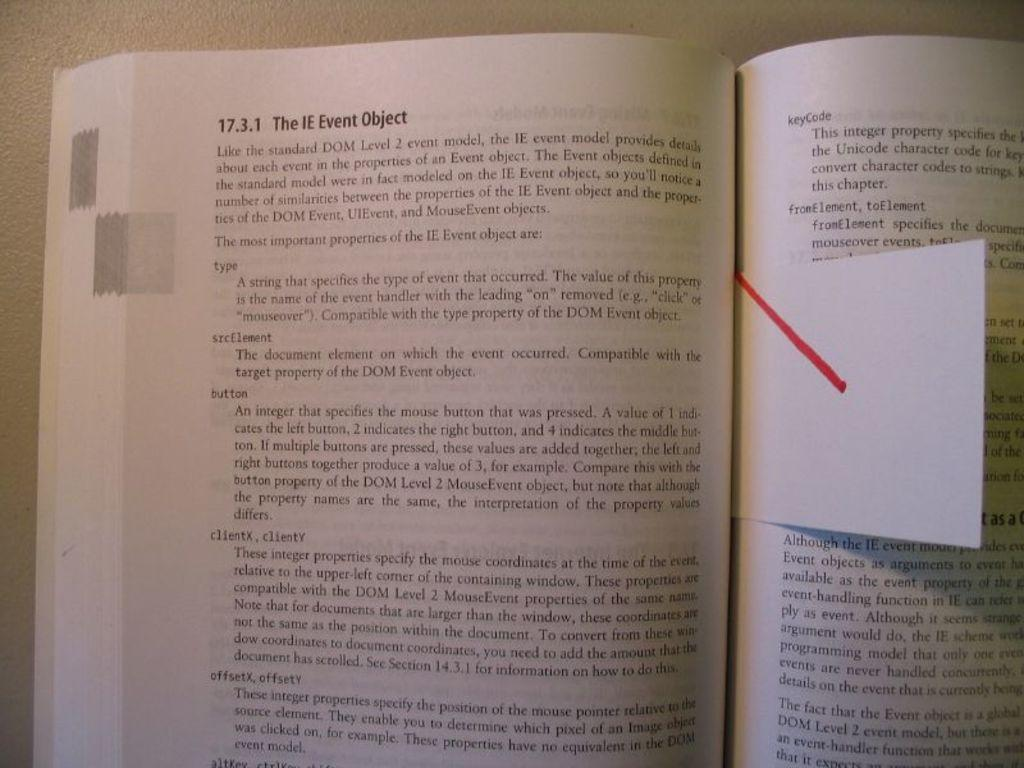<image>
Offer a succinct explanation of the picture presented. A book is opened and bookmarked on a page about The IE Event Object. 